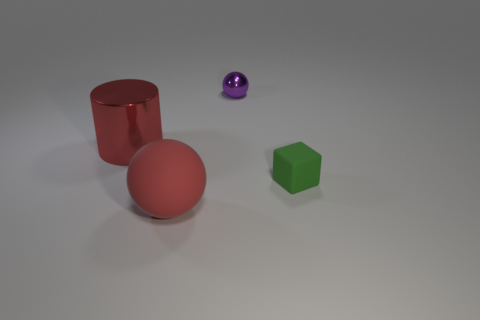What materials do the objects in the image appear to be made of? The objects in the image appear to be computer-generated models with matte surfaces. The red cylinder and sphere have a slightly less reflective surface that may suggest a rubber-like material. The purple sphere appears more reflective, indicating a possibly metallic or plastic material, and the green cube appears to have a matte finish, which could imply a plastic or wooden texture. 